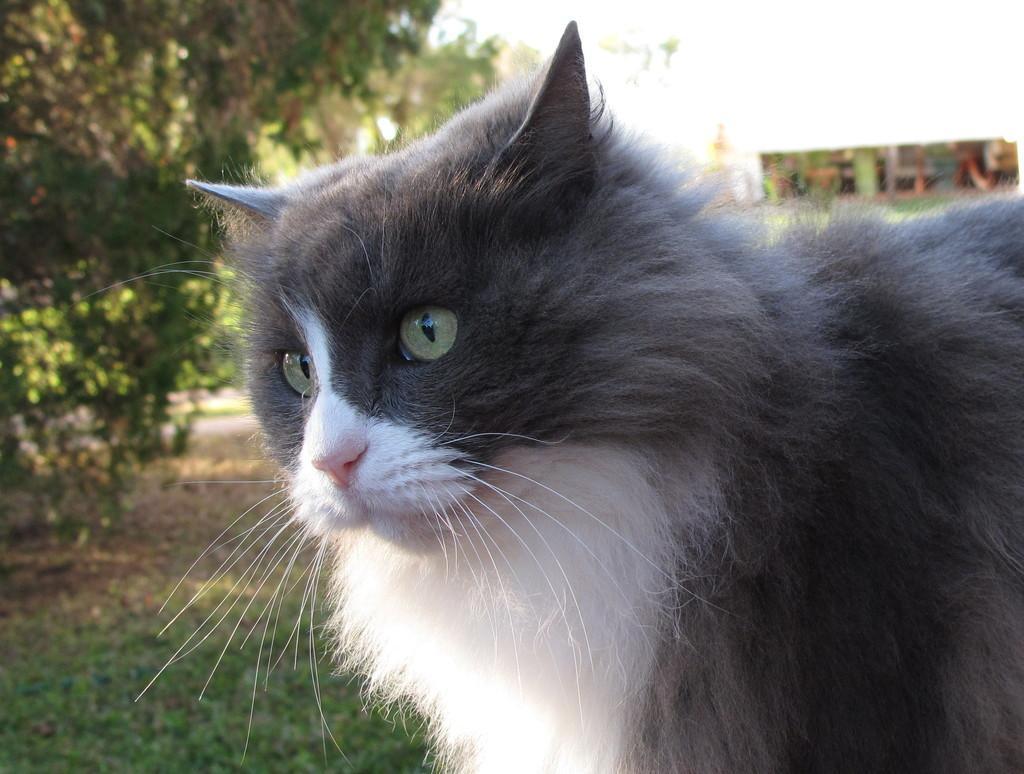Describe this image in one or two sentences. In this image there is a cat, at the bottom there is grassland, in the top left there is a tree. 